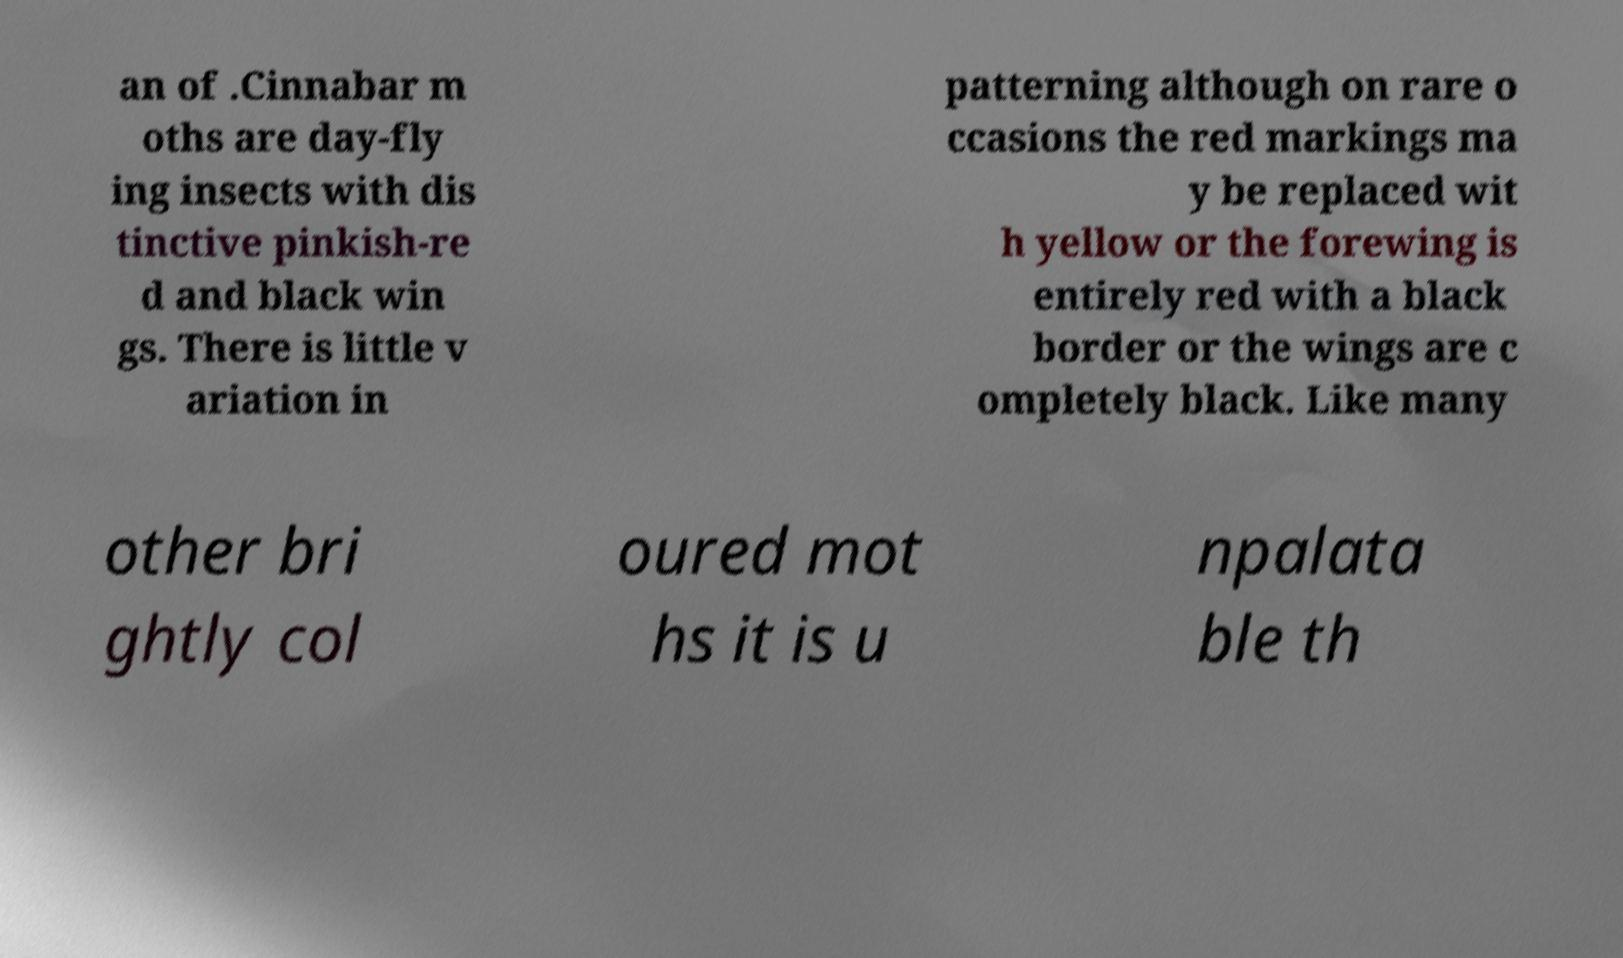Please read and relay the text visible in this image. What does it say? an of .Cinnabar m oths are day-fly ing insects with dis tinctive pinkish-re d and black win gs. There is little v ariation in patterning although on rare o ccasions the red markings ma y be replaced wit h yellow or the forewing is entirely red with a black border or the wings are c ompletely black. Like many other bri ghtly col oured mot hs it is u npalata ble th 